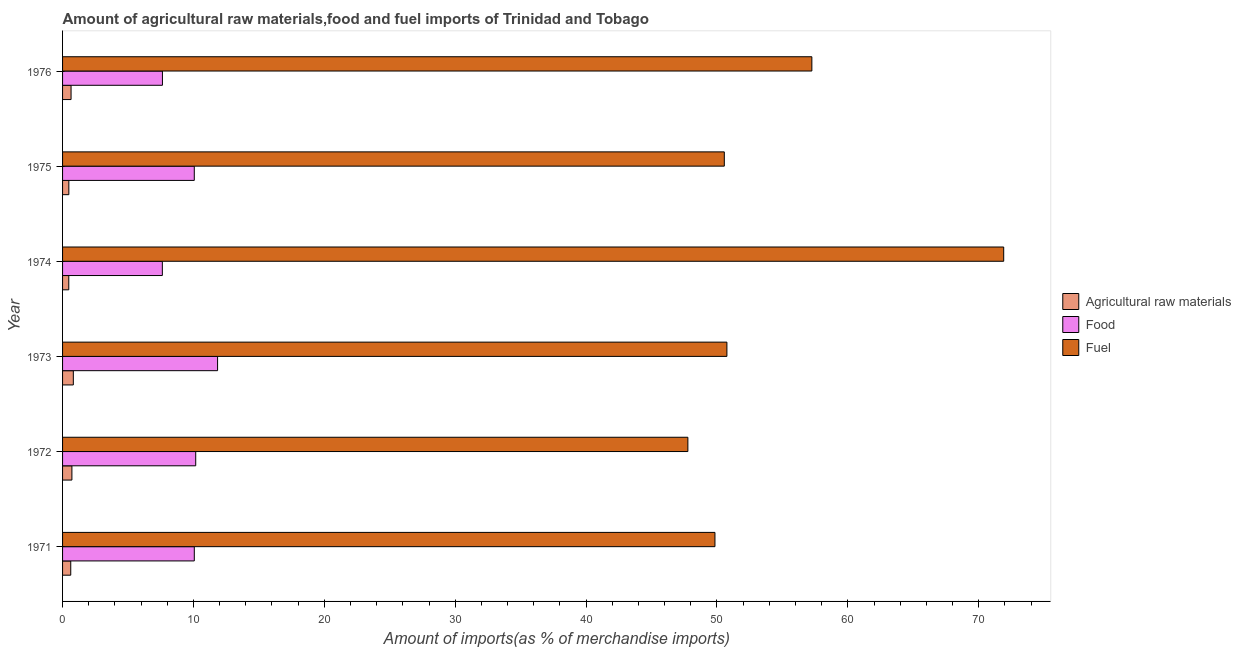How many groups of bars are there?
Give a very brief answer. 6. Are the number of bars per tick equal to the number of legend labels?
Your answer should be very brief. Yes. What is the label of the 6th group of bars from the top?
Your answer should be compact. 1971. What is the percentage of food imports in 1971?
Offer a very short reply. 10.06. Across all years, what is the maximum percentage of raw materials imports?
Offer a terse response. 0.82. Across all years, what is the minimum percentage of food imports?
Your response must be concise. 7.62. In which year was the percentage of fuel imports maximum?
Your answer should be compact. 1974. What is the total percentage of fuel imports in the graph?
Provide a succinct answer. 328.1. What is the difference between the percentage of raw materials imports in 1974 and that in 1975?
Provide a succinct answer. -0. What is the difference between the percentage of food imports in 1971 and the percentage of raw materials imports in 1976?
Your answer should be very brief. 9.42. What is the average percentage of food imports per year?
Your response must be concise. 9.57. In the year 1974, what is the difference between the percentage of raw materials imports and percentage of food imports?
Provide a short and direct response. -7.15. In how many years, is the percentage of food imports greater than 30 %?
Your response must be concise. 0. What is the difference between the highest and the second highest percentage of raw materials imports?
Your answer should be compact. 0.11. What is the difference between the highest and the lowest percentage of food imports?
Offer a terse response. 4.22. What does the 3rd bar from the top in 1976 represents?
Offer a terse response. Agricultural raw materials. What does the 2nd bar from the bottom in 1975 represents?
Keep it short and to the point. Food. Is it the case that in every year, the sum of the percentage of raw materials imports and percentage of food imports is greater than the percentage of fuel imports?
Provide a short and direct response. No. How many bars are there?
Your response must be concise. 18. Are all the bars in the graph horizontal?
Make the answer very short. Yes. What is the difference between two consecutive major ticks on the X-axis?
Your response must be concise. 10. Where does the legend appear in the graph?
Offer a terse response. Center right. How many legend labels are there?
Provide a short and direct response. 3. How are the legend labels stacked?
Offer a terse response. Vertical. What is the title of the graph?
Give a very brief answer. Amount of agricultural raw materials,food and fuel imports of Trinidad and Tobago. Does "Taxes on income" appear as one of the legend labels in the graph?
Provide a short and direct response. No. What is the label or title of the X-axis?
Your answer should be compact. Amount of imports(as % of merchandise imports). What is the Amount of imports(as % of merchandise imports) of Agricultural raw materials in 1971?
Provide a short and direct response. 0.62. What is the Amount of imports(as % of merchandise imports) in Food in 1971?
Your response must be concise. 10.06. What is the Amount of imports(as % of merchandise imports) in Fuel in 1971?
Your answer should be compact. 49.85. What is the Amount of imports(as % of merchandise imports) of Agricultural raw materials in 1972?
Provide a short and direct response. 0.71. What is the Amount of imports(as % of merchandise imports) in Food in 1972?
Ensure brevity in your answer.  10.17. What is the Amount of imports(as % of merchandise imports) of Fuel in 1972?
Your answer should be very brief. 47.78. What is the Amount of imports(as % of merchandise imports) in Agricultural raw materials in 1973?
Ensure brevity in your answer.  0.82. What is the Amount of imports(as % of merchandise imports) in Food in 1973?
Your response must be concise. 11.84. What is the Amount of imports(as % of merchandise imports) in Fuel in 1973?
Make the answer very short. 50.76. What is the Amount of imports(as % of merchandise imports) of Agricultural raw materials in 1974?
Your answer should be compact. 0.47. What is the Amount of imports(as % of merchandise imports) of Food in 1974?
Give a very brief answer. 7.62. What is the Amount of imports(as % of merchandise imports) of Fuel in 1974?
Your answer should be very brief. 71.91. What is the Amount of imports(as % of merchandise imports) in Agricultural raw materials in 1975?
Make the answer very short. 0.48. What is the Amount of imports(as % of merchandise imports) of Food in 1975?
Your answer should be very brief. 10.06. What is the Amount of imports(as % of merchandise imports) in Fuel in 1975?
Provide a succinct answer. 50.56. What is the Amount of imports(as % of merchandise imports) in Agricultural raw materials in 1976?
Offer a terse response. 0.65. What is the Amount of imports(as % of merchandise imports) of Food in 1976?
Provide a succinct answer. 7.63. What is the Amount of imports(as % of merchandise imports) in Fuel in 1976?
Provide a succinct answer. 57.25. Across all years, what is the maximum Amount of imports(as % of merchandise imports) of Agricultural raw materials?
Provide a succinct answer. 0.82. Across all years, what is the maximum Amount of imports(as % of merchandise imports) of Food?
Keep it short and to the point. 11.84. Across all years, what is the maximum Amount of imports(as % of merchandise imports) in Fuel?
Make the answer very short. 71.91. Across all years, what is the minimum Amount of imports(as % of merchandise imports) in Agricultural raw materials?
Ensure brevity in your answer.  0.47. Across all years, what is the minimum Amount of imports(as % of merchandise imports) in Food?
Ensure brevity in your answer.  7.62. Across all years, what is the minimum Amount of imports(as % of merchandise imports) of Fuel?
Offer a terse response. 47.78. What is the total Amount of imports(as % of merchandise imports) in Agricultural raw materials in the graph?
Your answer should be compact. 3.76. What is the total Amount of imports(as % of merchandise imports) in Food in the graph?
Your answer should be compact. 57.4. What is the total Amount of imports(as % of merchandise imports) in Fuel in the graph?
Your response must be concise. 328.1. What is the difference between the Amount of imports(as % of merchandise imports) of Agricultural raw materials in 1971 and that in 1972?
Make the answer very short. -0.09. What is the difference between the Amount of imports(as % of merchandise imports) of Food in 1971 and that in 1972?
Ensure brevity in your answer.  -0.11. What is the difference between the Amount of imports(as % of merchandise imports) of Fuel in 1971 and that in 1972?
Your answer should be compact. 2.07. What is the difference between the Amount of imports(as % of merchandise imports) in Agricultural raw materials in 1971 and that in 1973?
Offer a terse response. -0.2. What is the difference between the Amount of imports(as % of merchandise imports) in Food in 1971 and that in 1973?
Give a very brief answer. -1.78. What is the difference between the Amount of imports(as % of merchandise imports) of Fuel in 1971 and that in 1973?
Ensure brevity in your answer.  -0.91. What is the difference between the Amount of imports(as % of merchandise imports) in Agricultural raw materials in 1971 and that in 1974?
Provide a succinct answer. 0.15. What is the difference between the Amount of imports(as % of merchandise imports) of Food in 1971 and that in 1974?
Ensure brevity in your answer.  2.44. What is the difference between the Amount of imports(as % of merchandise imports) in Fuel in 1971 and that in 1974?
Your response must be concise. -22.06. What is the difference between the Amount of imports(as % of merchandise imports) of Agricultural raw materials in 1971 and that in 1975?
Provide a succinct answer. 0.15. What is the difference between the Amount of imports(as % of merchandise imports) of Food in 1971 and that in 1975?
Ensure brevity in your answer.  0. What is the difference between the Amount of imports(as % of merchandise imports) of Fuel in 1971 and that in 1975?
Ensure brevity in your answer.  -0.72. What is the difference between the Amount of imports(as % of merchandise imports) in Agricultural raw materials in 1971 and that in 1976?
Ensure brevity in your answer.  -0.02. What is the difference between the Amount of imports(as % of merchandise imports) of Food in 1971 and that in 1976?
Your response must be concise. 2.43. What is the difference between the Amount of imports(as % of merchandise imports) in Fuel in 1971 and that in 1976?
Ensure brevity in your answer.  -7.41. What is the difference between the Amount of imports(as % of merchandise imports) in Agricultural raw materials in 1972 and that in 1973?
Provide a succinct answer. -0.11. What is the difference between the Amount of imports(as % of merchandise imports) in Food in 1972 and that in 1973?
Keep it short and to the point. -1.67. What is the difference between the Amount of imports(as % of merchandise imports) of Fuel in 1972 and that in 1973?
Your answer should be very brief. -2.98. What is the difference between the Amount of imports(as % of merchandise imports) in Agricultural raw materials in 1972 and that in 1974?
Your response must be concise. 0.24. What is the difference between the Amount of imports(as % of merchandise imports) of Food in 1972 and that in 1974?
Ensure brevity in your answer.  2.55. What is the difference between the Amount of imports(as % of merchandise imports) of Fuel in 1972 and that in 1974?
Provide a succinct answer. -24.13. What is the difference between the Amount of imports(as % of merchandise imports) of Agricultural raw materials in 1972 and that in 1975?
Ensure brevity in your answer.  0.23. What is the difference between the Amount of imports(as % of merchandise imports) of Food in 1972 and that in 1975?
Offer a very short reply. 0.11. What is the difference between the Amount of imports(as % of merchandise imports) in Fuel in 1972 and that in 1975?
Make the answer very short. -2.78. What is the difference between the Amount of imports(as % of merchandise imports) of Agricultural raw materials in 1972 and that in 1976?
Make the answer very short. 0.06. What is the difference between the Amount of imports(as % of merchandise imports) of Food in 1972 and that in 1976?
Your answer should be very brief. 2.54. What is the difference between the Amount of imports(as % of merchandise imports) of Fuel in 1972 and that in 1976?
Keep it short and to the point. -9.47. What is the difference between the Amount of imports(as % of merchandise imports) in Agricultural raw materials in 1973 and that in 1974?
Ensure brevity in your answer.  0.35. What is the difference between the Amount of imports(as % of merchandise imports) of Food in 1973 and that in 1974?
Offer a terse response. 4.22. What is the difference between the Amount of imports(as % of merchandise imports) of Fuel in 1973 and that in 1974?
Keep it short and to the point. -21.15. What is the difference between the Amount of imports(as % of merchandise imports) of Agricultural raw materials in 1973 and that in 1975?
Offer a very short reply. 0.34. What is the difference between the Amount of imports(as % of merchandise imports) of Food in 1973 and that in 1975?
Give a very brief answer. 1.78. What is the difference between the Amount of imports(as % of merchandise imports) of Fuel in 1973 and that in 1975?
Make the answer very short. 0.2. What is the difference between the Amount of imports(as % of merchandise imports) in Agricultural raw materials in 1973 and that in 1976?
Provide a short and direct response. 0.17. What is the difference between the Amount of imports(as % of merchandise imports) of Food in 1973 and that in 1976?
Keep it short and to the point. 4.21. What is the difference between the Amount of imports(as % of merchandise imports) in Fuel in 1973 and that in 1976?
Your response must be concise. -6.49. What is the difference between the Amount of imports(as % of merchandise imports) in Agricultural raw materials in 1974 and that in 1975?
Your answer should be compact. -0. What is the difference between the Amount of imports(as % of merchandise imports) in Food in 1974 and that in 1975?
Your answer should be very brief. -2.44. What is the difference between the Amount of imports(as % of merchandise imports) in Fuel in 1974 and that in 1975?
Ensure brevity in your answer.  21.35. What is the difference between the Amount of imports(as % of merchandise imports) in Agricultural raw materials in 1974 and that in 1976?
Make the answer very short. -0.17. What is the difference between the Amount of imports(as % of merchandise imports) in Food in 1974 and that in 1976?
Your answer should be very brief. -0.01. What is the difference between the Amount of imports(as % of merchandise imports) of Fuel in 1974 and that in 1976?
Provide a short and direct response. 14.66. What is the difference between the Amount of imports(as % of merchandise imports) of Agricultural raw materials in 1975 and that in 1976?
Give a very brief answer. -0.17. What is the difference between the Amount of imports(as % of merchandise imports) in Food in 1975 and that in 1976?
Offer a terse response. 2.43. What is the difference between the Amount of imports(as % of merchandise imports) of Fuel in 1975 and that in 1976?
Make the answer very short. -6.69. What is the difference between the Amount of imports(as % of merchandise imports) in Agricultural raw materials in 1971 and the Amount of imports(as % of merchandise imports) in Food in 1972?
Keep it short and to the point. -9.55. What is the difference between the Amount of imports(as % of merchandise imports) in Agricultural raw materials in 1971 and the Amount of imports(as % of merchandise imports) in Fuel in 1972?
Provide a short and direct response. -47.15. What is the difference between the Amount of imports(as % of merchandise imports) in Food in 1971 and the Amount of imports(as % of merchandise imports) in Fuel in 1972?
Offer a terse response. -37.71. What is the difference between the Amount of imports(as % of merchandise imports) in Agricultural raw materials in 1971 and the Amount of imports(as % of merchandise imports) in Food in 1973?
Your answer should be very brief. -11.22. What is the difference between the Amount of imports(as % of merchandise imports) of Agricultural raw materials in 1971 and the Amount of imports(as % of merchandise imports) of Fuel in 1973?
Offer a very short reply. -50.13. What is the difference between the Amount of imports(as % of merchandise imports) of Food in 1971 and the Amount of imports(as % of merchandise imports) of Fuel in 1973?
Your answer should be compact. -40.69. What is the difference between the Amount of imports(as % of merchandise imports) of Agricultural raw materials in 1971 and the Amount of imports(as % of merchandise imports) of Food in 1974?
Provide a short and direct response. -7. What is the difference between the Amount of imports(as % of merchandise imports) of Agricultural raw materials in 1971 and the Amount of imports(as % of merchandise imports) of Fuel in 1974?
Provide a short and direct response. -71.28. What is the difference between the Amount of imports(as % of merchandise imports) of Food in 1971 and the Amount of imports(as % of merchandise imports) of Fuel in 1974?
Your answer should be very brief. -61.84. What is the difference between the Amount of imports(as % of merchandise imports) of Agricultural raw materials in 1971 and the Amount of imports(as % of merchandise imports) of Food in 1975?
Ensure brevity in your answer.  -9.44. What is the difference between the Amount of imports(as % of merchandise imports) in Agricultural raw materials in 1971 and the Amount of imports(as % of merchandise imports) in Fuel in 1975?
Your response must be concise. -49.94. What is the difference between the Amount of imports(as % of merchandise imports) in Food in 1971 and the Amount of imports(as % of merchandise imports) in Fuel in 1975?
Offer a terse response. -40.5. What is the difference between the Amount of imports(as % of merchandise imports) in Agricultural raw materials in 1971 and the Amount of imports(as % of merchandise imports) in Food in 1976?
Your response must be concise. -7.01. What is the difference between the Amount of imports(as % of merchandise imports) in Agricultural raw materials in 1971 and the Amount of imports(as % of merchandise imports) in Fuel in 1976?
Your answer should be very brief. -56.63. What is the difference between the Amount of imports(as % of merchandise imports) of Food in 1971 and the Amount of imports(as % of merchandise imports) of Fuel in 1976?
Give a very brief answer. -47.19. What is the difference between the Amount of imports(as % of merchandise imports) of Agricultural raw materials in 1972 and the Amount of imports(as % of merchandise imports) of Food in 1973?
Your response must be concise. -11.13. What is the difference between the Amount of imports(as % of merchandise imports) of Agricultural raw materials in 1972 and the Amount of imports(as % of merchandise imports) of Fuel in 1973?
Offer a terse response. -50.05. What is the difference between the Amount of imports(as % of merchandise imports) in Food in 1972 and the Amount of imports(as % of merchandise imports) in Fuel in 1973?
Your response must be concise. -40.59. What is the difference between the Amount of imports(as % of merchandise imports) in Agricultural raw materials in 1972 and the Amount of imports(as % of merchandise imports) in Food in 1974?
Ensure brevity in your answer.  -6.91. What is the difference between the Amount of imports(as % of merchandise imports) in Agricultural raw materials in 1972 and the Amount of imports(as % of merchandise imports) in Fuel in 1974?
Make the answer very short. -71.2. What is the difference between the Amount of imports(as % of merchandise imports) of Food in 1972 and the Amount of imports(as % of merchandise imports) of Fuel in 1974?
Your answer should be very brief. -61.74. What is the difference between the Amount of imports(as % of merchandise imports) in Agricultural raw materials in 1972 and the Amount of imports(as % of merchandise imports) in Food in 1975?
Provide a short and direct response. -9.35. What is the difference between the Amount of imports(as % of merchandise imports) in Agricultural raw materials in 1972 and the Amount of imports(as % of merchandise imports) in Fuel in 1975?
Your answer should be very brief. -49.85. What is the difference between the Amount of imports(as % of merchandise imports) in Food in 1972 and the Amount of imports(as % of merchandise imports) in Fuel in 1975?
Your answer should be compact. -40.39. What is the difference between the Amount of imports(as % of merchandise imports) of Agricultural raw materials in 1972 and the Amount of imports(as % of merchandise imports) of Food in 1976?
Your answer should be compact. -6.92. What is the difference between the Amount of imports(as % of merchandise imports) of Agricultural raw materials in 1972 and the Amount of imports(as % of merchandise imports) of Fuel in 1976?
Your answer should be very brief. -56.54. What is the difference between the Amount of imports(as % of merchandise imports) in Food in 1972 and the Amount of imports(as % of merchandise imports) in Fuel in 1976?
Your response must be concise. -47.08. What is the difference between the Amount of imports(as % of merchandise imports) of Agricultural raw materials in 1973 and the Amount of imports(as % of merchandise imports) of Food in 1974?
Offer a terse response. -6.8. What is the difference between the Amount of imports(as % of merchandise imports) in Agricultural raw materials in 1973 and the Amount of imports(as % of merchandise imports) in Fuel in 1974?
Ensure brevity in your answer.  -71.09. What is the difference between the Amount of imports(as % of merchandise imports) of Food in 1973 and the Amount of imports(as % of merchandise imports) of Fuel in 1974?
Your answer should be compact. -60.06. What is the difference between the Amount of imports(as % of merchandise imports) of Agricultural raw materials in 1973 and the Amount of imports(as % of merchandise imports) of Food in 1975?
Give a very brief answer. -9.24. What is the difference between the Amount of imports(as % of merchandise imports) in Agricultural raw materials in 1973 and the Amount of imports(as % of merchandise imports) in Fuel in 1975?
Offer a very short reply. -49.74. What is the difference between the Amount of imports(as % of merchandise imports) of Food in 1973 and the Amount of imports(as % of merchandise imports) of Fuel in 1975?
Provide a short and direct response. -38.72. What is the difference between the Amount of imports(as % of merchandise imports) in Agricultural raw materials in 1973 and the Amount of imports(as % of merchandise imports) in Food in 1976?
Offer a terse response. -6.81. What is the difference between the Amount of imports(as % of merchandise imports) of Agricultural raw materials in 1973 and the Amount of imports(as % of merchandise imports) of Fuel in 1976?
Provide a succinct answer. -56.43. What is the difference between the Amount of imports(as % of merchandise imports) in Food in 1973 and the Amount of imports(as % of merchandise imports) in Fuel in 1976?
Provide a short and direct response. -45.41. What is the difference between the Amount of imports(as % of merchandise imports) of Agricultural raw materials in 1974 and the Amount of imports(as % of merchandise imports) of Food in 1975?
Give a very brief answer. -9.59. What is the difference between the Amount of imports(as % of merchandise imports) in Agricultural raw materials in 1974 and the Amount of imports(as % of merchandise imports) in Fuel in 1975?
Provide a succinct answer. -50.09. What is the difference between the Amount of imports(as % of merchandise imports) of Food in 1974 and the Amount of imports(as % of merchandise imports) of Fuel in 1975?
Offer a very short reply. -42.94. What is the difference between the Amount of imports(as % of merchandise imports) in Agricultural raw materials in 1974 and the Amount of imports(as % of merchandise imports) in Food in 1976?
Offer a terse response. -7.16. What is the difference between the Amount of imports(as % of merchandise imports) in Agricultural raw materials in 1974 and the Amount of imports(as % of merchandise imports) in Fuel in 1976?
Ensure brevity in your answer.  -56.78. What is the difference between the Amount of imports(as % of merchandise imports) of Food in 1974 and the Amount of imports(as % of merchandise imports) of Fuel in 1976?
Ensure brevity in your answer.  -49.63. What is the difference between the Amount of imports(as % of merchandise imports) in Agricultural raw materials in 1975 and the Amount of imports(as % of merchandise imports) in Food in 1976?
Make the answer very short. -7.15. What is the difference between the Amount of imports(as % of merchandise imports) in Agricultural raw materials in 1975 and the Amount of imports(as % of merchandise imports) in Fuel in 1976?
Offer a terse response. -56.77. What is the difference between the Amount of imports(as % of merchandise imports) in Food in 1975 and the Amount of imports(as % of merchandise imports) in Fuel in 1976?
Your response must be concise. -47.19. What is the average Amount of imports(as % of merchandise imports) of Agricultural raw materials per year?
Your answer should be very brief. 0.63. What is the average Amount of imports(as % of merchandise imports) of Food per year?
Ensure brevity in your answer.  9.57. What is the average Amount of imports(as % of merchandise imports) in Fuel per year?
Your answer should be compact. 54.68. In the year 1971, what is the difference between the Amount of imports(as % of merchandise imports) in Agricultural raw materials and Amount of imports(as % of merchandise imports) in Food?
Your response must be concise. -9.44. In the year 1971, what is the difference between the Amount of imports(as % of merchandise imports) in Agricultural raw materials and Amount of imports(as % of merchandise imports) in Fuel?
Ensure brevity in your answer.  -49.22. In the year 1971, what is the difference between the Amount of imports(as % of merchandise imports) in Food and Amount of imports(as % of merchandise imports) in Fuel?
Make the answer very short. -39.78. In the year 1972, what is the difference between the Amount of imports(as % of merchandise imports) of Agricultural raw materials and Amount of imports(as % of merchandise imports) of Food?
Ensure brevity in your answer.  -9.46. In the year 1972, what is the difference between the Amount of imports(as % of merchandise imports) in Agricultural raw materials and Amount of imports(as % of merchandise imports) in Fuel?
Your answer should be compact. -47.06. In the year 1972, what is the difference between the Amount of imports(as % of merchandise imports) of Food and Amount of imports(as % of merchandise imports) of Fuel?
Your response must be concise. -37.6. In the year 1973, what is the difference between the Amount of imports(as % of merchandise imports) in Agricultural raw materials and Amount of imports(as % of merchandise imports) in Food?
Provide a succinct answer. -11.02. In the year 1973, what is the difference between the Amount of imports(as % of merchandise imports) in Agricultural raw materials and Amount of imports(as % of merchandise imports) in Fuel?
Your response must be concise. -49.94. In the year 1973, what is the difference between the Amount of imports(as % of merchandise imports) in Food and Amount of imports(as % of merchandise imports) in Fuel?
Give a very brief answer. -38.92. In the year 1974, what is the difference between the Amount of imports(as % of merchandise imports) of Agricultural raw materials and Amount of imports(as % of merchandise imports) of Food?
Offer a very short reply. -7.15. In the year 1974, what is the difference between the Amount of imports(as % of merchandise imports) in Agricultural raw materials and Amount of imports(as % of merchandise imports) in Fuel?
Provide a succinct answer. -71.43. In the year 1974, what is the difference between the Amount of imports(as % of merchandise imports) in Food and Amount of imports(as % of merchandise imports) in Fuel?
Ensure brevity in your answer.  -64.28. In the year 1975, what is the difference between the Amount of imports(as % of merchandise imports) in Agricultural raw materials and Amount of imports(as % of merchandise imports) in Food?
Your answer should be compact. -9.59. In the year 1975, what is the difference between the Amount of imports(as % of merchandise imports) in Agricultural raw materials and Amount of imports(as % of merchandise imports) in Fuel?
Your response must be concise. -50.08. In the year 1975, what is the difference between the Amount of imports(as % of merchandise imports) in Food and Amount of imports(as % of merchandise imports) in Fuel?
Make the answer very short. -40.5. In the year 1976, what is the difference between the Amount of imports(as % of merchandise imports) in Agricultural raw materials and Amount of imports(as % of merchandise imports) in Food?
Your response must be concise. -6.98. In the year 1976, what is the difference between the Amount of imports(as % of merchandise imports) in Agricultural raw materials and Amount of imports(as % of merchandise imports) in Fuel?
Ensure brevity in your answer.  -56.6. In the year 1976, what is the difference between the Amount of imports(as % of merchandise imports) in Food and Amount of imports(as % of merchandise imports) in Fuel?
Your answer should be very brief. -49.62. What is the ratio of the Amount of imports(as % of merchandise imports) in Agricultural raw materials in 1971 to that in 1972?
Your answer should be compact. 0.88. What is the ratio of the Amount of imports(as % of merchandise imports) in Food in 1971 to that in 1972?
Provide a succinct answer. 0.99. What is the ratio of the Amount of imports(as % of merchandise imports) of Fuel in 1971 to that in 1972?
Your answer should be compact. 1.04. What is the ratio of the Amount of imports(as % of merchandise imports) in Agricultural raw materials in 1971 to that in 1973?
Keep it short and to the point. 0.76. What is the ratio of the Amount of imports(as % of merchandise imports) in Food in 1971 to that in 1973?
Offer a terse response. 0.85. What is the ratio of the Amount of imports(as % of merchandise imports) in Fuel in 1971 to that in 1973?
Give a very brief answer. 0.98. What is the ratio of the Amount of imports(as % of merchandise imports) of Agricultural raw materials in 1971 to that in 1974?
Make the answer very short. 1.32. What is the ratio of the Amount of imports(as % of merchandise imports) of Food in 1971 to that in 1974?
Give a very brief answer. 1.32. What is the ratio of the Amount of imports(as % of merchandise imports) of Fuel in 1971 to that in 1974?
Ensure brevity in your answer.  0.69. What is the ratio of the Amount of imports(as % of merchandise imports) of Agricultural raw materials in 1971 to that in 1975?
Your response must be concise. 1.3. What is the ratio of the Amount of imports(as % of merchandise imports) of Food in 1971 to that in 1975?
Provide a short and direct response. 1. What is the ratio of the Amount of imports(as % of merchandise imports) of Fuel in 1971 to that in 1975?
Keep it short and to the point. 0.99. What is the ratio of the Amount of imports(as % of merchandise imports) of Agricultural raw materials in 1971 to that in 1976?
Provide a succinct answer. 0.96. What is the ratio of the Amount of imports(as % of merchandise imports) in Food in 1971 to that in 1976?
Keep it short and to the point. 1.32. What is the ratio of the Amount of imports(as % of merchandise imports) in Fuel in 1971 to that in 1976?
Provide a short and direct response. 0.87. What is the ratio of the Amount of imports(as % of merchandise imports) in Agricultural raw materials in 1972 to that in 1973?
Provide a succinct answer. 0.87. What is the ratio of the Amount of imports(as % of merchandise imports) in Food in 1972 to that in 1973?
Give a very brief answer. 0.86. What is the ratio of the Amount of imports(as % of merchandise imports) in Fuel in 1972 to that in 1973?
Make the answer very short. 0.94. What is the ratio of the Amount of imports(as % of merchandise imports) of Agricultural raw materials in 1972 to that in 1974?
Offer a terse response. 1.5. What is the ratio of the Amount of imports(as % of merchandise imports) in Food in 1972 to that in 1974?
Give a very brief answer. 1.33. What is the ratio of the Amount of imports(as % of merchandise imports) of Fuel in 1972 to that in 1974?
Provide a succinct answer. 0.66. What is the ratio of the Amount of imports(as % of merchandise imports) in Agricultural raw materials in 1972 to that in 1975?
Offer a terse response. 1.49. What is the ratio of the Amount of imports(as % of merchandise imports) in Food in 1972 to that in 1975?
Your response must be concise. 1.01. What is the ratio of the Amount of imports(as % of merchandise imports) in Fuel in 1972 to that in 1975?
Give a very brief answer. 0.94. What is the ratio of the Amount of imports(as % of merchandise imports) of Agricultural raw materials in 1972 to that in 1976?
Offer a very short reply. 1.1. What is the ratio of the Amount of imports(as % of merchandise imports) of Food in 1972 to that in 1976?
Keep it short and to the point. 1.33. What is the ratio of the Amount of imports(as % of merchandise imports) of Fuel in 1972 to that in 1976?
Offer a very short reply. 0.83. What is the ratio of the Amount of imports(as % of merchandise imports) in Agricultural raw materials in 1973 to that in 1974?
Your response must be concise. 1.73. What is the ratio of the Amount of imports(as % of merchandise imports) in Food in 1973 to that in 1974?
Offer a very short reply. 1.55. What is the ratio of the Amount of imports(as % of merchandise imports) of Fuel in 1973 to that in 1974?
Ensure brevity in your answer.  0.71. What is the ratio of the Amount of imports(as % of merchandise imports) of Agricultural raw materials in 1973 to that in 1975?
Your response must be concise. 1.71. What is the ratio of the Amount of imports(as % of merchandise imports) in Food in 1973 to that in 1975?
Offer a very short reply. 1.18. What is the ratio of the Amount of imports(as % of merchandise imports) in Fuel in 1973 to that in 1975?
Provide a short and direct response. 1. What is the ratio of the Amount of imports(as % of merchandise imports) in Agricultural raw materials in 1973 to that in 1976?
Ensure brevity in your answer.  1.27. What is the ratio of the Amount of imports(as % of merchandise imports) of Food in 1973 to that in 1976?
Make the answer very short. 1.55. What is the ratio of the Amount of imports(as % of merchandise imports) of Fuel in 1973 to that in 1976?
Offer a terse response. 0.89. What is the ratio of the Amount of imports(as % of merchandise imports) of Agricultural raw materials in 1974 to that in 1975?
Your answer should be very brief. 0.99. What is the ratio of the Amount of imports(as % of merchandise imports) of Food in 1974 to that in 1975?
Offer a terse response. 0.76. What is the ratio of the Amount of imports(as % of merchandise imports) in Fuel in 1974 to that in 1975?
Your answer should be compact. 1.42. What is the ratio of the Amount of imports(as % of merchandise imports) of Agricultural raw materials in 1974 to that in 1976?
Make the answer very short. 0.73. What is the ratio of the Amount of imports(as % of merchandise imports) of Food in 1974 to that in 1976?
Your response must be concise. 1. What is the ratio of the Amount of imports(as % of merchandise imports) in Fuel in 1974 to that in 1976?
Provide a succinct answer. 1.26. What is the ratio of the Amount of imports(as % of merchandise imports) in Agricultural raw materials in 1975 to that in 1976?
Ensure brevity in your answer.  0.74. What is the ratio of the Amount of imports(as % of merchandise imports) of Food in 1975 to that in 1976?
Give a very brief answer. 1.32. What is the ratio of the Amount of imports(as % of merchandise imports) in Fuel in 1975 to that in 1976?
Offer a very short reply. 0.88. What is the difference between the highest and the second highest Amount of imports(as % of merchandise imports) in Agricultural raw materials?
Your response must be concise. 0.11. What is the difference between the highest and the second highest Amount of imports(as % of merchandise imports) in Food?
Your response must be concise. 1.67. What is the difference between the highest and the second highest Amount of imports(as % of merchandise imports) of Fuel?
Keep it short and to the point. 14.66. What is the difference between the highest and the lowest Amount of imports(as % of merchandise imports) of Agricultural raw materials?
Give a very brief answer. 0.35. What is the difference between the highest and the lowest Amount of imports(as % of merchandise imports) of Food?
Make the answer very short. 4.22. What is the difference between the highest and the lowest Amount of imports(as % of merchandise imports) of Fuel?
Give a very brief answer. 24.13. 